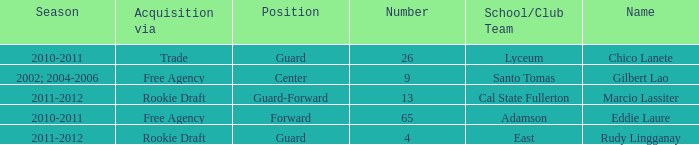What season had Marcio Lassiter? 2011-2012. 